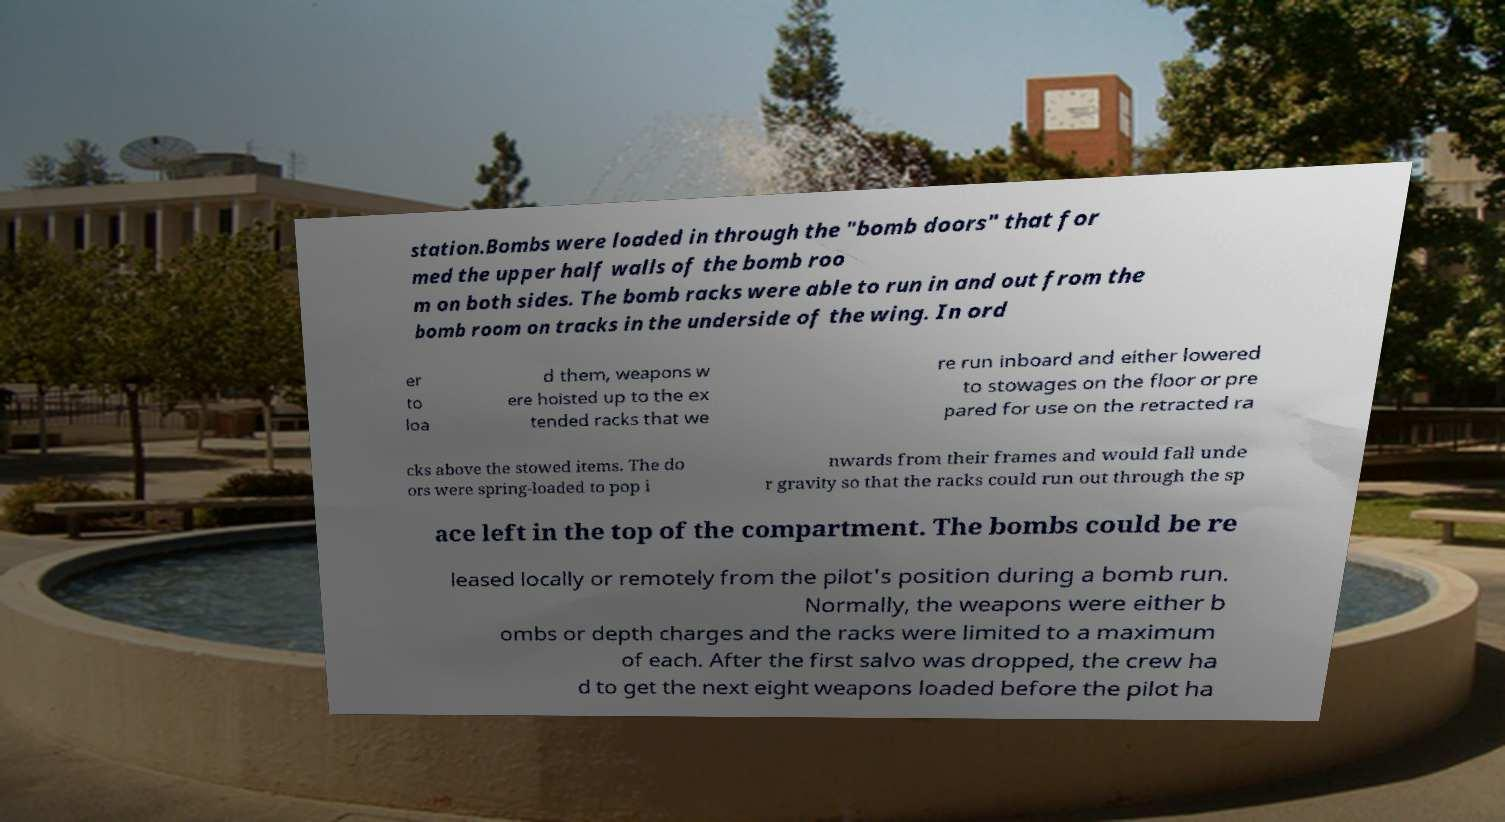What messages or text are displayed in this image? I need them in a readable, typed format. station.Bombs were loaded in through the "bomb doors" that for med the upper half walls of the bomb roo m on both sides. The bomb racks were able to run in and out from the bomb room on tracks in the underside of the wing. In ord er to loa d them, weapons w ere hoisted up to the ex tended racks that we re run inboard and either lowered to stowages on the floor or pre pared for use on the retracted ra cks above the stowed items. The do ors were spring-loaded to pop i nwards from their frames and would fall unde r gravity so that the racks could run out through the sp ace left in the top of the compartment. The bombs could be re leased locally or remotely from the pilot's position during a bomb run. Normally, the weapons were either b ombs or depth charges and the racks were limited to a maximum of each. After the first salvo was dropped, the crew ha d to get the next eight weapons loaded before the pilot ha 